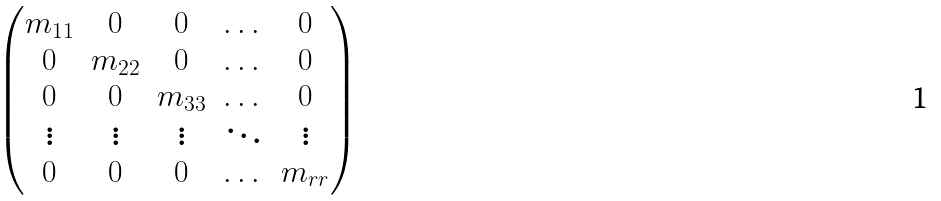Convert formula to latex. <formula><loc_0><loc_0><loc_500><loc_500>\begin{pmatrix} m _ { 1 1 } & 0 & 0 & \dots & 0 \\ 0 & m _ { 2 2 } & 0 & \dots & 0 \\ 0 & 0 & m _ { 3 3 } & \dots & 0 \\ \vdots & \vdots & \vdots & \ddots & \vdots \\ 0 & 0 & 0 & \dots & m _ { r r } \end{pmatrix}</formula> 